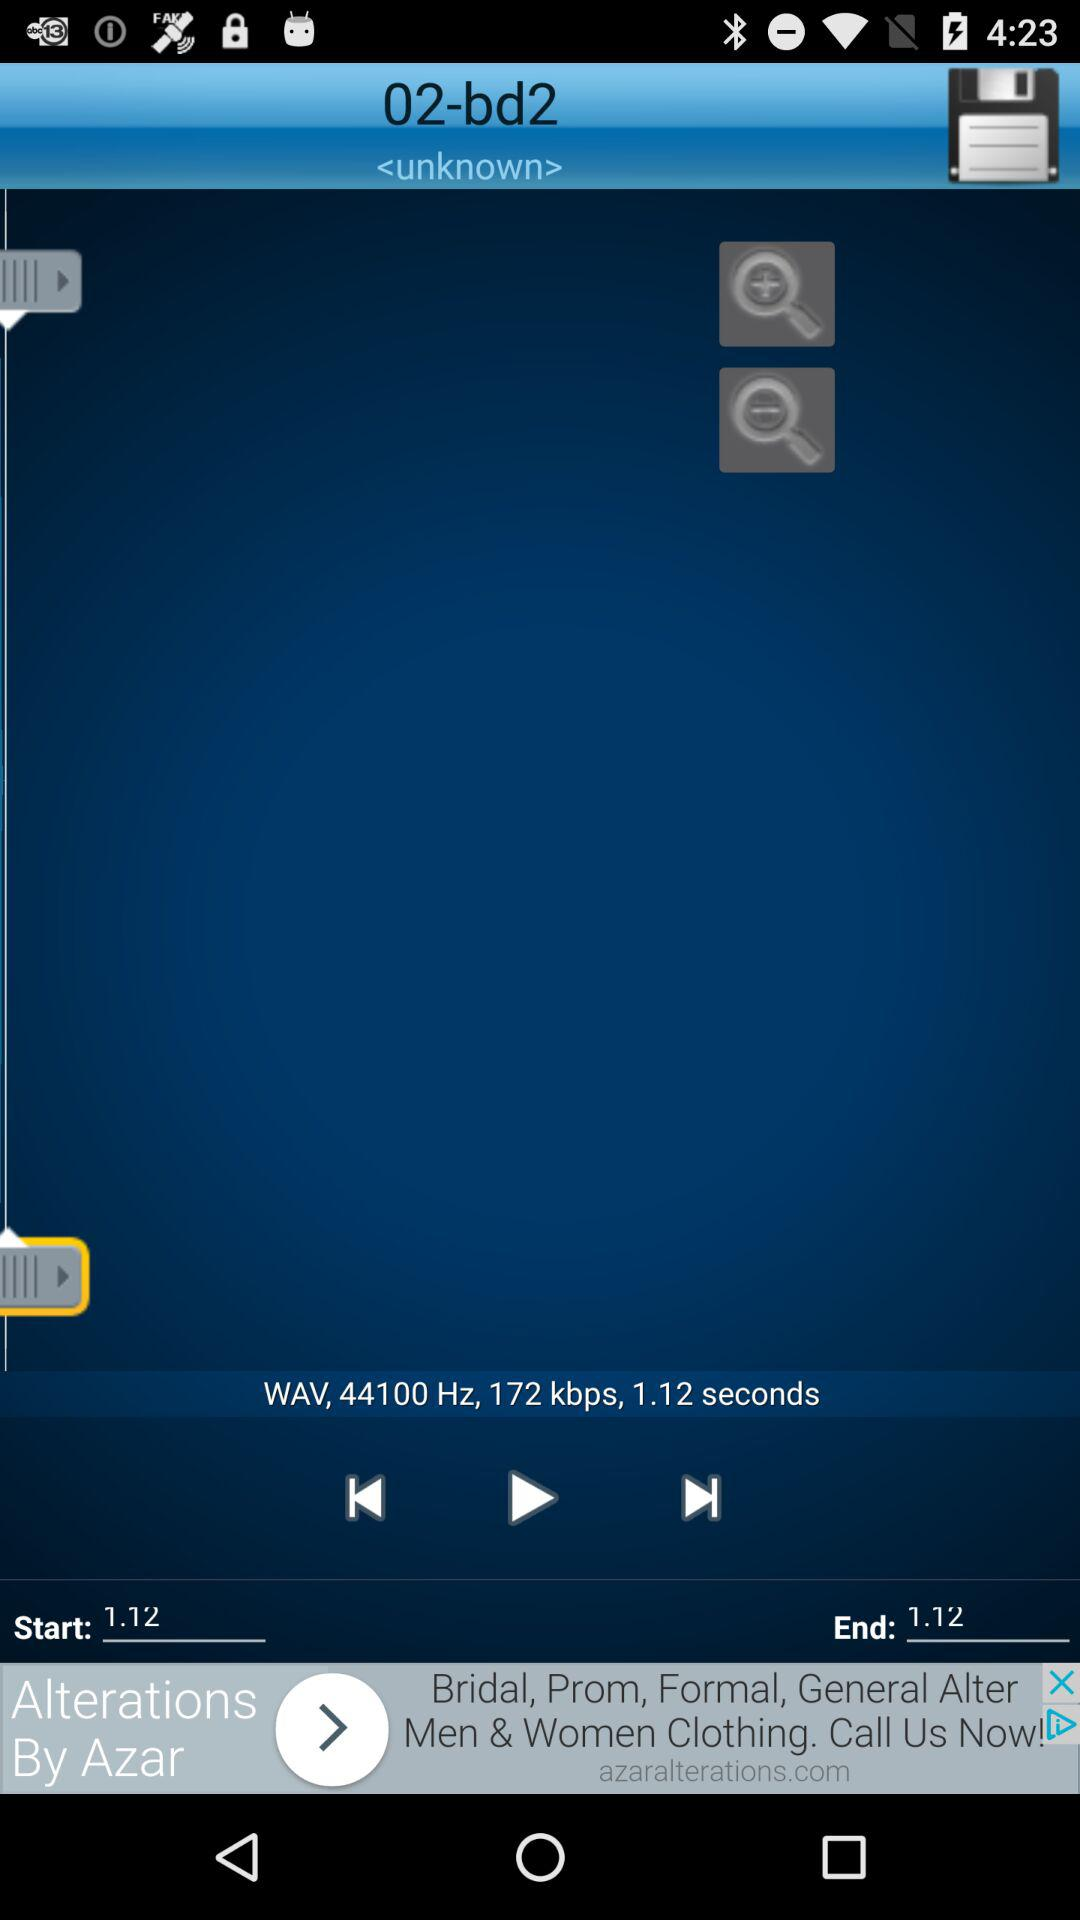What is the end time? The end time is 1.12. 